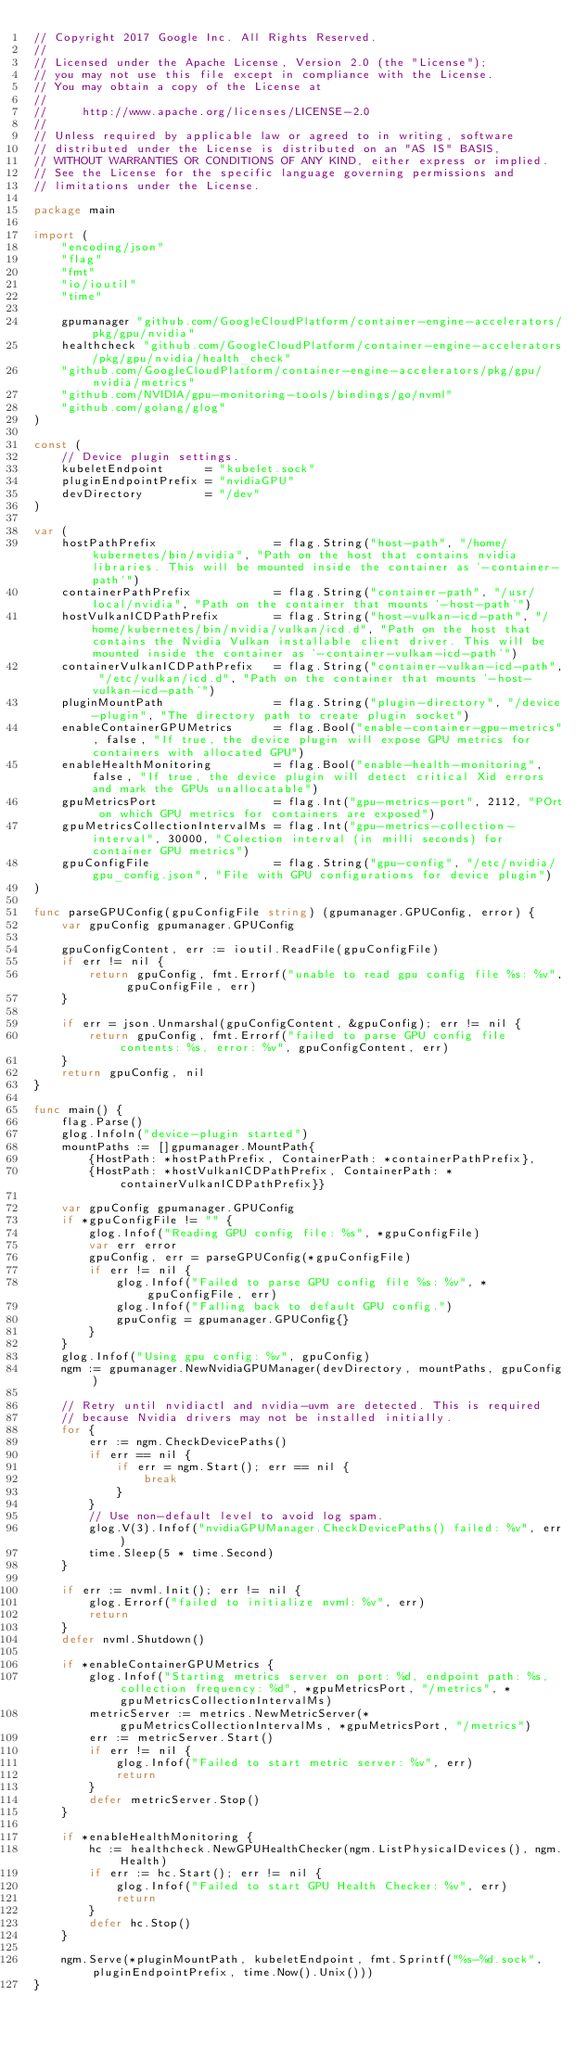Convert code to text. <code><loc_0><loc_0><loc_500><loc_500><_Go_>// Copyright 2017 Google Inc. All Rights Reserved.
//
// Licensed under the Apache License, Version 2.0 (the "License");
// you may not use this file except in compliance with the License.
// You may obtain a copy of the License at
//
//     http://www.apache.org/licenses/LICENSE-2.0
//
// Unless required by applicable law or agreed to in writing, software
// distributed under the License is distributed on an "AS IS" BASIS,
// WITHOUT WARRANTIES OR CONDITIONS OF ANY KIND, either express or implied.
// See the License for the specific language governing permissions and
// limitations under the License.

package main

import (
	"encoding/json"
	"flag"
	"fmt"
	"io/ioutil"
	"time"

	gpumanager "github.com/GoogleCloudPlatform/container-engine-accelerators/pkg/gpu/nvidia"
	healthcheck "github.com/GoogleCloudPlatform/container-engine-accelerators/pkg/gpu/nvidia/health_check"
	"github.com/GoogleCloudPlatform/container-engine-accelerators/pkg/gpu/nvidia/metrics"
	"github.com/NVIDIA/gpu-monitoring-tools/bindings/go/nvml"
	"github.com/golang/glog"
)

const (
	// Device plugin settings.
	kubeletEndpoint      = "kubelet.sock"
	pluginEndpointPrefix = "nvidiaGPU"
	devDirectory         = "/dev"
)

var (
	hostPathPrefix                 = flag.String("host-path", "/home/kubernetes/bin/nvidia", "Path on the host that contains nvidia libraries. This will be mounted inside the container as '-container-path'")
	containerPathPrefix            = flag.String("container-path", "/usr/local/nvidia", "Path on the container that mounts '-host-path'")
	hostVulkanICDPathPrefix        = flag.String("host-vulkan-icd-path", "/home/kubernetes/bin/nvidia/vulkan/icd.d", "Path on the host that contains the Nvidia Vulkan installable client driver. This will be mounted inside the container as '-container-vulkan-icd-path'")
	containerVulkanICDPathPrefix   = flag.String("container-vulkan-icd-path", "/etc/vulkan/icd.d", "Path on the container that mounts '-host-vulkan-icd-path'")
	pluginMountPath                = flag.String("plugin-directory", "/device-plugin", "The directory path to create plugin socket")
	enableContainerGPUMetrics      = flag.Bool("enable-container-gpu-metrics", false, "If true, the device plugin will expose GPU metrics for containers with allocated GPU")
	enableHealthMonitoring         = flag.Bool("enable-health-monitoring", false, "If true, the device plugin will detect critical Xid errors and mark the GPUs unallocatable")
	gpuMetricsPort                 = flag.Int("gpu-metrics-port", 2112, "POrt on which GPU metrics for containers are exposed")
	gpuMetricsCollectionIntervalMs = flag.Int("gpu-metrics-collection-interval", 30000, "Colection interval (in milli seconds) for container GPU metrics")
	gpuConfigFile                  = flag.String("gpu-config", "/etc/nvidia/gpu_config.json", "File with GPU configurations for device plugin")
)

func parseGPUConfig(gpuConfigFile string) (gpumanager.GPUConfig, error) {
	var gpuConfig gpumanager.GPUConfig

	gpuConfigContent, err := ioutil.ReadFile(gpuConfigFile)
	if err != nil {
		return gpuConfig, fmt.Errorf("unable to read gpu config file %s: %v", gpuConfigFile, err)
	}

	if err = json.Unmarshal(gpuConfigContent, &gpuConfig); err != nil {
		return gpuConfig, fmt.Errorf("failed to parse GPU config file contents: %s, error: %v", gpuConfigContent, err)
	}
	return gpuConfig, nil
}

func main() {
	flag.Parse()
	glog.Infoln("device-plugin started")
	mountPaths := []gpumanager.MountPath{
		{HostPath: *hostPathPrefix, ContainerPath: *containerPathPrefix},
		{HostPath: *hostVulkanICDPathPrefix, ContainerPath: *containerVulkanICDPathPrefix}}

	var gpuConfig gpumanager.GPUConfig
	if *gpuConfigFile != "" {
		glog.Infof("Reading GPU config file: %s", *gpuConfigFile)
		var err error
		gpuConfig, err = parseGPUConfig(*gpuConfigFile)
		if err != nil {
			glog.Infof("Failed to parse GPU config file %s: %v", *gpuConfigFile, err)
			glog.Infof("Falling back to default GPU config.")
			gpuConfig = gpumanager.GPUConfig{}
		}
	}
	glog.Infof("Using gpu config: %v", gpuConfig)
	ngm := gpumanager.NewNvidiaGPUManager(devDirectory, mountPaths, gpuConfig)

	// Retry until nvidiactl and nvidia-uvm are detected. This is required
	// because Nvidia drivers may not be installed initially.
	for {
		err := ngm.CheckDevicePaths()
		if err == nil {
			if err = ngm.Start(); err == nil {
				break
			}
		}
		// Use non-default level to avoid log spam.
		glog.V(3).Infof("nvidiaGPUManager.CheckDevicePaths() failed: %v", err)
		time.Sleep(5 * time.Second)
	}

	if err := nvml.Init(); err != nil {
		glog.Errorf("failed to initialize nvml: %v", err)
		return
	}
	defer nvml.Shutdown()

	if *enableContainerGPUMetrics {
		glog.Infof("Starting metrics server on port: %d, endpoint path: %s, collection frequency: %d", *gpuMetricsPort, "/metrics", *gpuMetricsCollectionIntervalMs)
		metricServer := metrics.NewMetricServer(*gpuMetricsCollectionIntervalMs, *gpuMetricsPort, "/metrics")
		err := metricServer.Start()
		if err != nil {
			glog.Infof("Failed to start metric server: %v", err)
			return
		}
		defer metricServer.Stop()
	}

	if *enableHealthMonitoring {
		hc := healthcheck.NewGPUHealthChecker(ngm.ListPhysicalDevices(), ngm.Health)
		if err := hc.Start(); err != nil {
			glog.Infof("Failed to start GPU Health Checker: %v", err)
			return
		}
		defer hc.Stop()
	}

	ngm.Serve(*pluginMountPath, kubeletEndpoint, fmt.Sprintf("%s-%d.sock", pluginEndpointPrefix, time.Now().Unix()))
}
</code> 